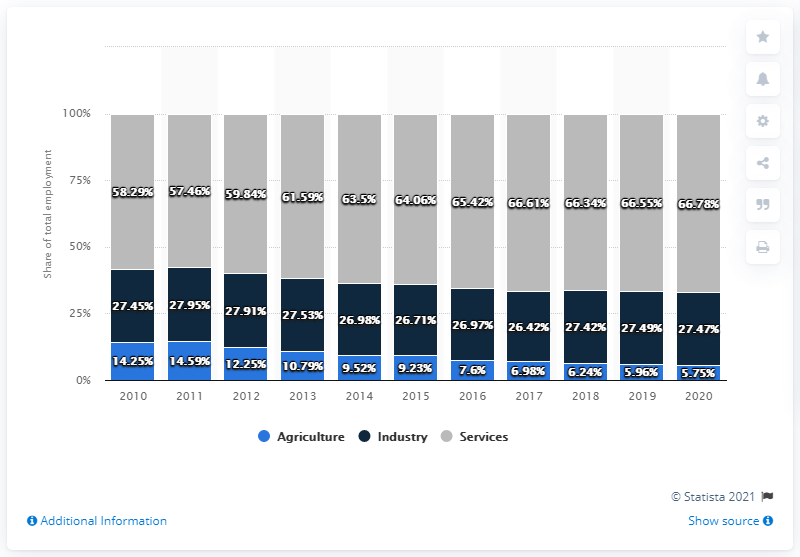Indicate a few pertinent items in this graphic. In 2018, the percentage share of the Industry sector in total employment was 27.42%. The difference between the maximum agricultural share and the minimum industrial share from 2010 to 2020 is 11.83. 